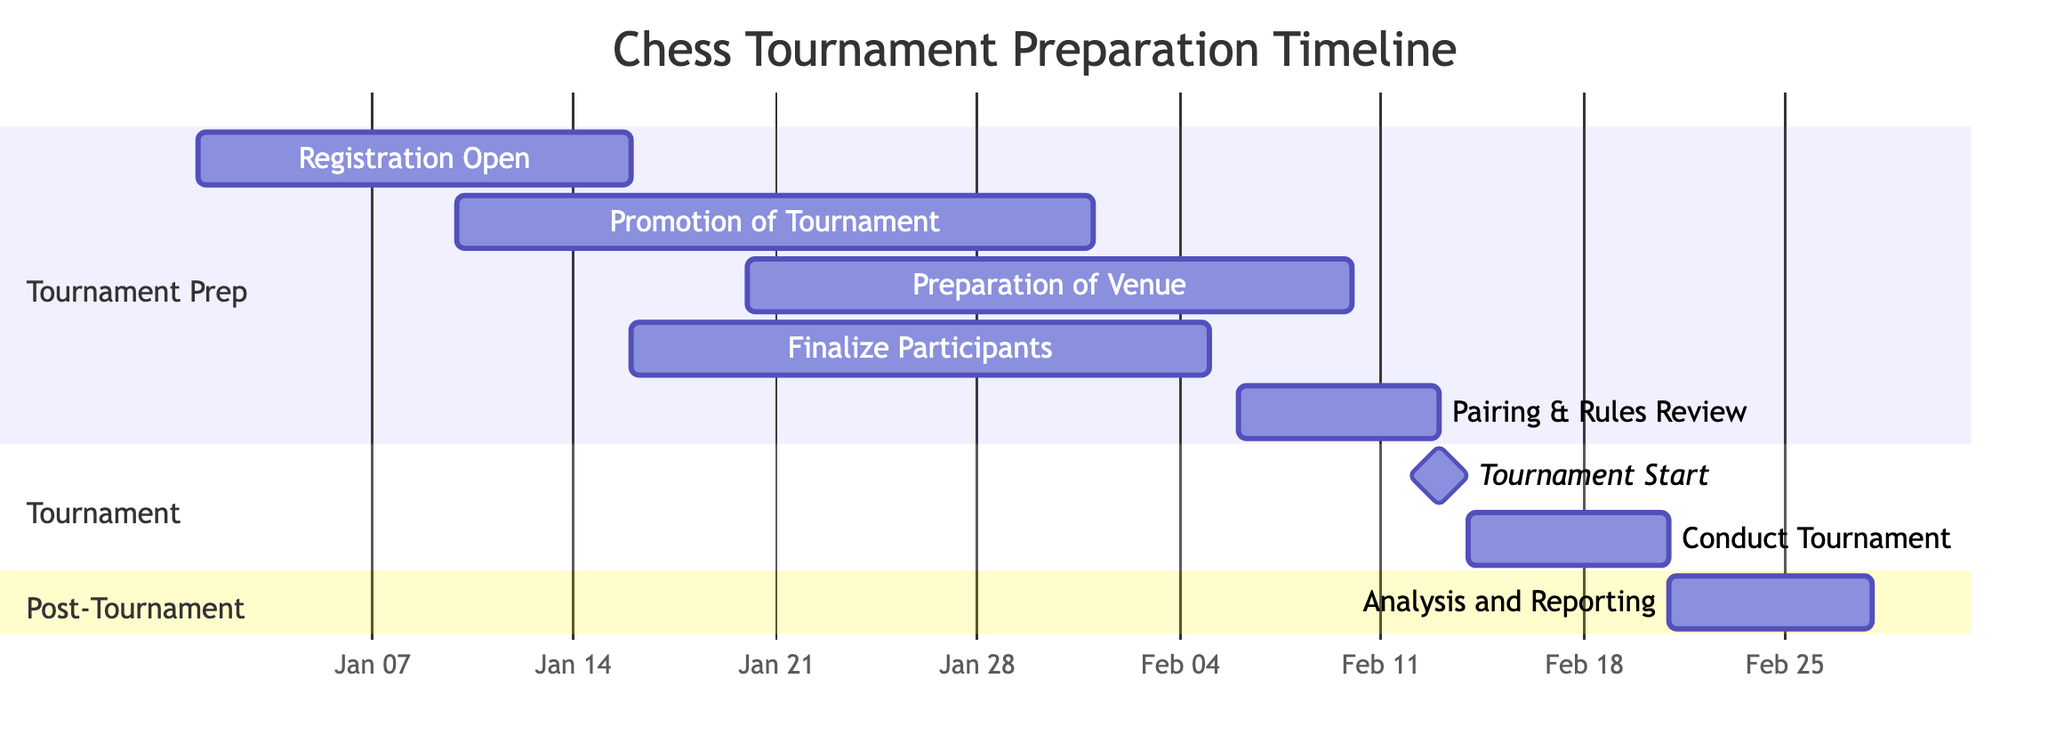What is the duration of the "Preparation of Tournament Venue" task? The "Preparation of Tournament Venue" task has a duration of 21 days as indicated in the diagram.
Answer: 21 days When does the "Conduct Tournament" task start? The "Conduct Tournament" task starts on February 14, 2024, as depicted in the timeline segment of the Gantt chart.
Answer: February 14, 2024 What task begins after "Finalize Participants"? The task that begins after "Finalize Participants" is "Pairing, Setup Rounds, and Game Rules Review," which starts on February 6, 2024, following the end of the "Finalize Participants" task on February 5, 2024.
Answer: Pairing, Setup Rounds, and Game Rules Review How many days overlap between the "Promotion of Tournament" and "Preparation of Tournament Venue"? There are 11 days of overlap between "Promotion of Tournament," which starts on January 10, 2024, and "Preparation of Tournament Venue," which starts on January 20, 2024. The overlap is calculated from January 20 to January 30 inclusive.
Answer: 11 days What is the end date of the "Post-Tournament Analysis and Reporting"? The "Post-Tournament Analysis and Reporting" task ends on February 27, 2024, as specified in the timeline, which starts on February 21, 2024.
Answer: February 27, 2024 Which task has no duration and serves as a milestone? The task with no duration and serves as a milestone is "Tournament Start," which occurs on February 13, 2024.
Answer: Tournament Start What is the total number of tasks in the Gantt chart? The total number of tasks in the Gantt chart is eight, counting all the tasks listed in the tournament preparation, tournament, and post-tournament sections.
Answer: Eight Which task overlaps the longest with the registration timeline? The "Promotion of Tournament" task overlaps the longest with the registration timeline, as it runs from January 10 to February 1, while registration is open from January 1 to January 15.
Answer: Promotion of Tournament 